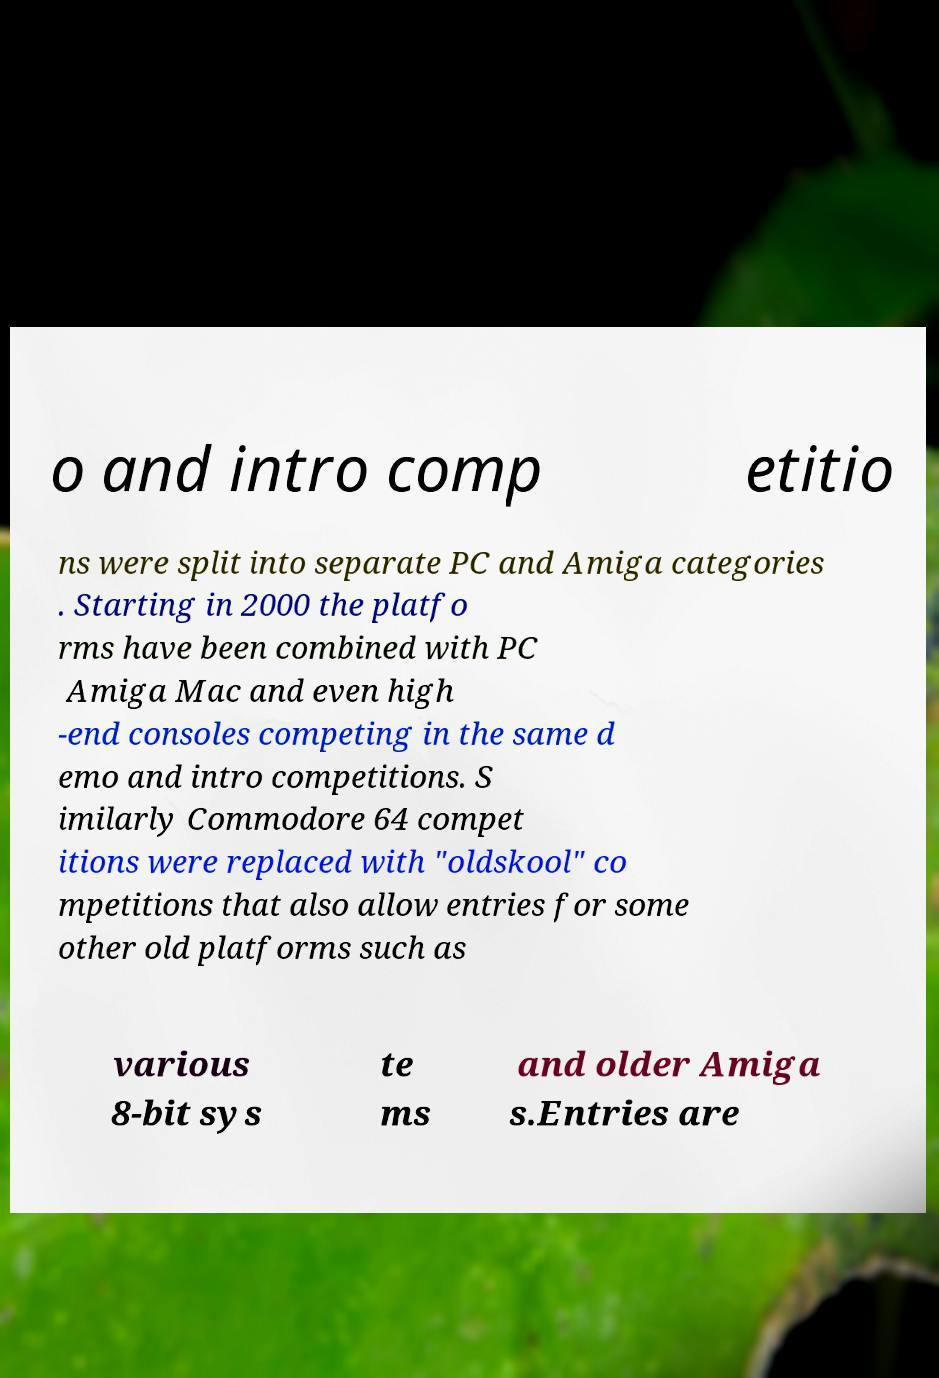For documentation purposes, I need the text within this image transcribed. Could you provide that? o and intro comp etitio ns were split into separate PC and Amiga categories . Starting in 2000 the platfo rms have been combined with PC Amiga Mac and even high -end consoles competing in the same d emo and intro competitions. S imilarly Commodore 64 compet itions were replaced with "oldskool" co mpetitions that also allow entries for some other old platforms such as various 8-bit sys te ms and older Amiga s.Entries are 